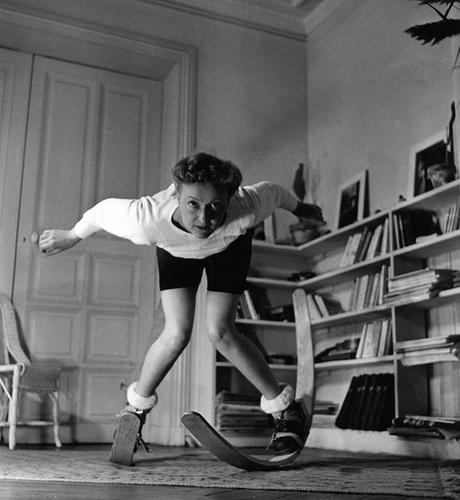What is the woman doing?
Quick response, please. Posing. Is this black and white?
Concise answer only. Yes. Are the woman's knees bent in the photo?
Write a very short answer. Yes. What sport is she playing?
Answer briefly. Skiing. 